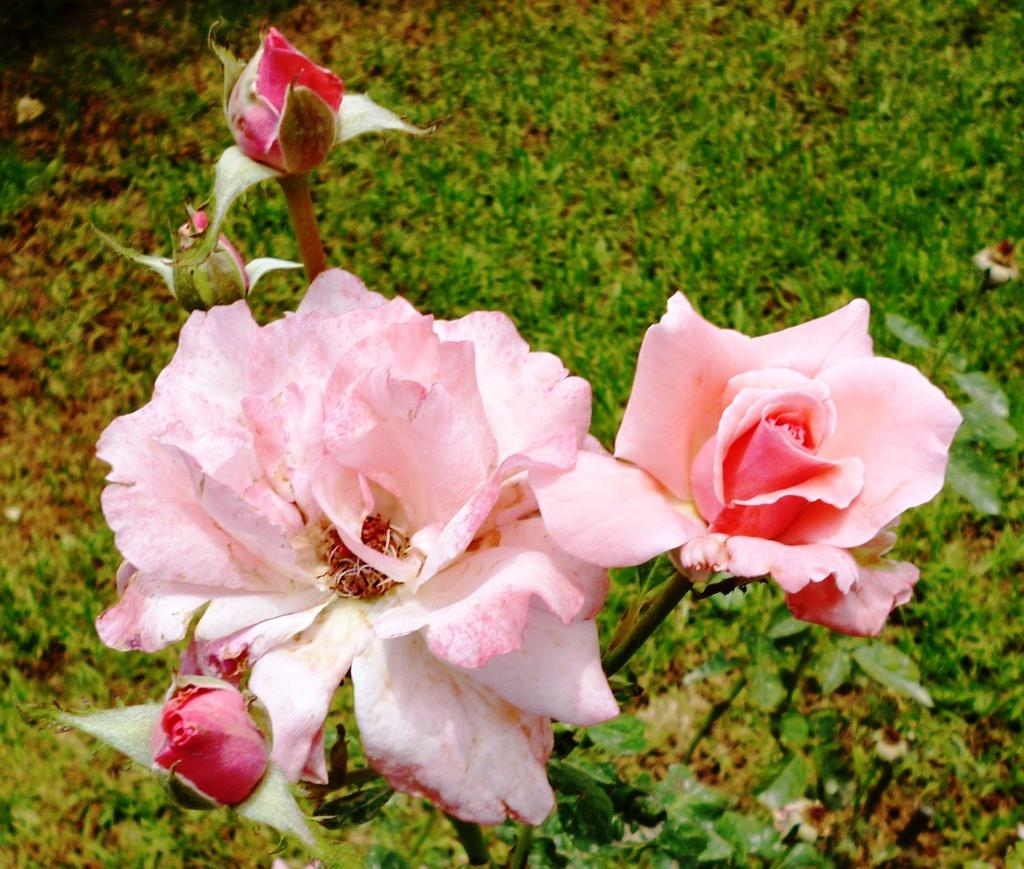What type of flowers are in the image? The image contains rose flowers. What color are the roses in the image? The roses are in pink color. What type of property can be seen in the image? There is no property visible in the image; it only contains pink rose flowers. What nerve is responsible for controlling the movement of the roses in the image? The image is a static representation and does not depict any movement, so there is no nerve controlling the movement of the roses. 